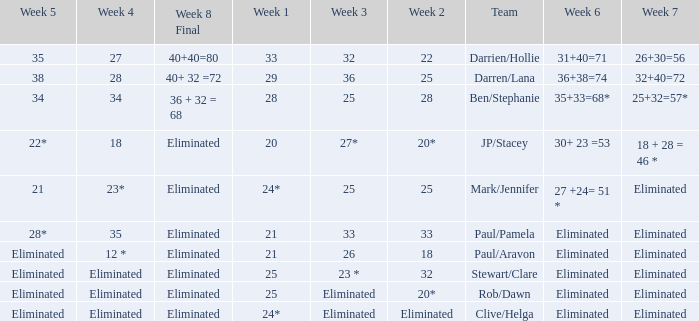Name the team for week 1 of 33 Darrien/Hollie. 